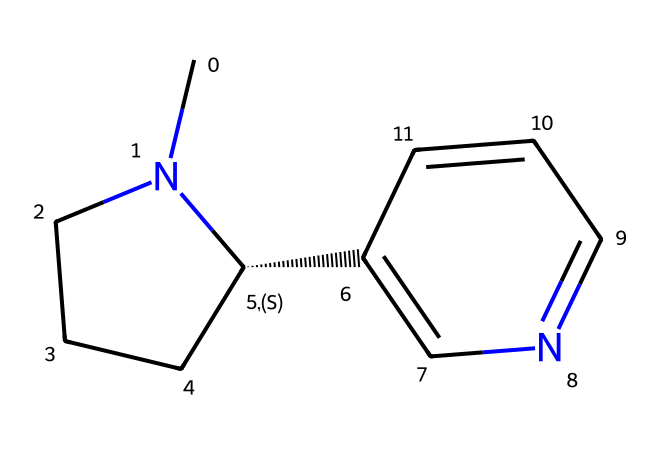What is the molecular formula of nicotine? To determine the molecular formula, count the number of each type of atom in the structure. From the SMILES representation, we have: 10 carbon (C) atoms, 14 hydrogen (H) atoms, and 1 nitrogen (N) atom. Thus, the formula is C10H14N2.
Answer: C10H14N2 How many rings are present in this chemical structure? Analyzing the SMILES, the presence of the "C" and "N" atoms linked in a cyclical manner indicates the presence of two rings in the structure.
Answer: 2 What functional group is primarily responsible for the basicity of nicotine? The nitrogen atom in the structure is part of the functional group that contributes to its basicity. The lone pair of electrons on the nitrogen allows it to accept protons, classifying it as a basic compound.
Answer: Nitrogen What is the number of double bonds in nicotine? By examining the structure from the SMILES, we can identify the connections. There is one double bond present in the structure.
Answer: 1 Which parts of the nicotine structure contribute to its addictive properties? The nitrogen atom facilitates interactions with nicotinic receptors in the brain, which plays a significant role in its addictive qualities. Connectivity through carbon rings also enhances its binding capability. Thus, the nitrogen and overall cyclic structure are critical contributors.
Answer: Nitrogen and cyclic structure Is nicotine a type of alkaloid or not? Based on the structure and classification, nicotine is characterized as an alkaloid due to the presence of nitrogen and its physiological effects. Alkaloids are compounds that contain basic nitrogen atoms used in pharmacological applications.
Answer: Yes 